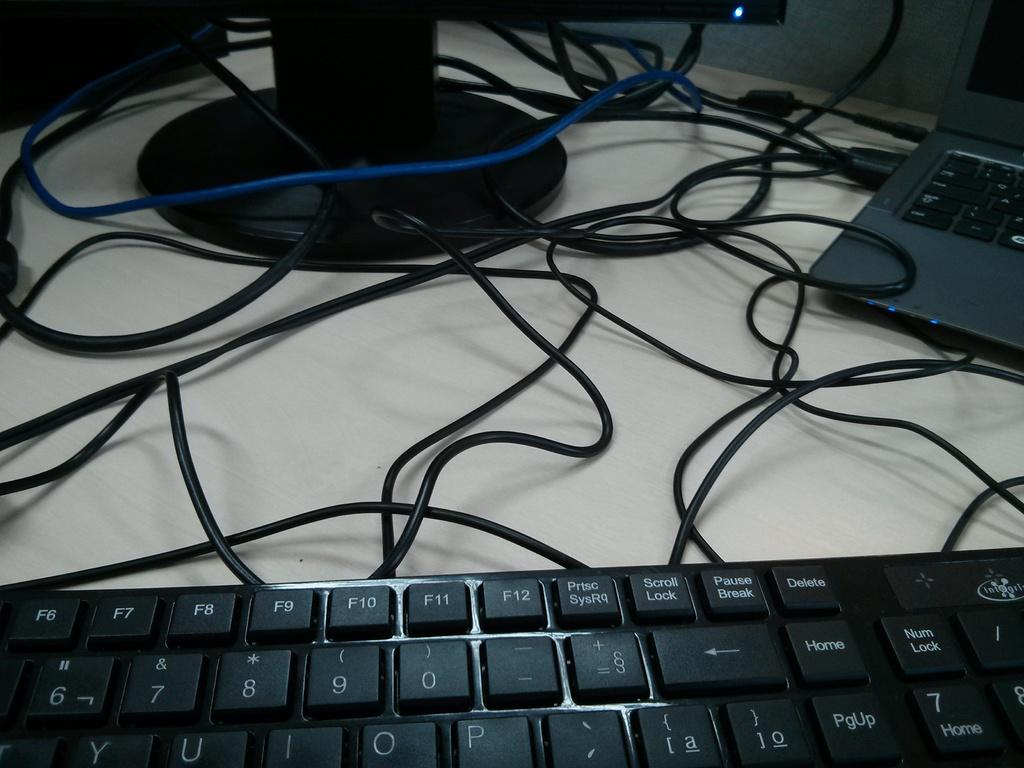<image>
Give a short and clear explanation of the subsequent image. Computer monitor with many cords and the Delete button near the top right. 